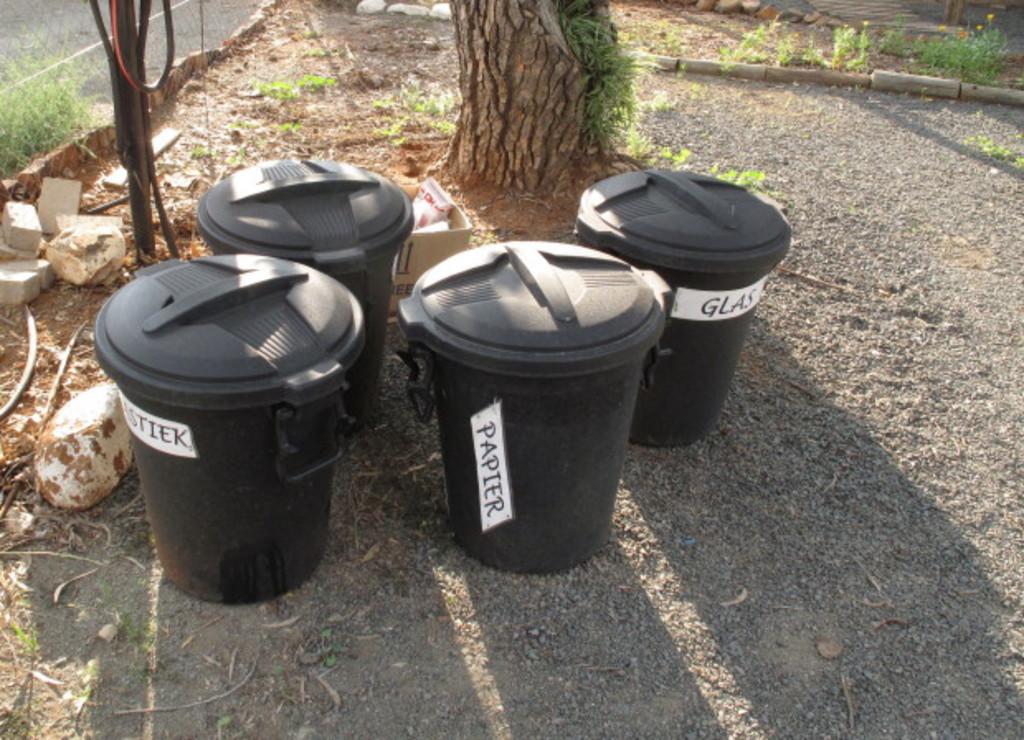What trash bin is in the middle?
Offer a terse response. Papier. What recycling bin is on the right?
Your response must be concise. Glass. 